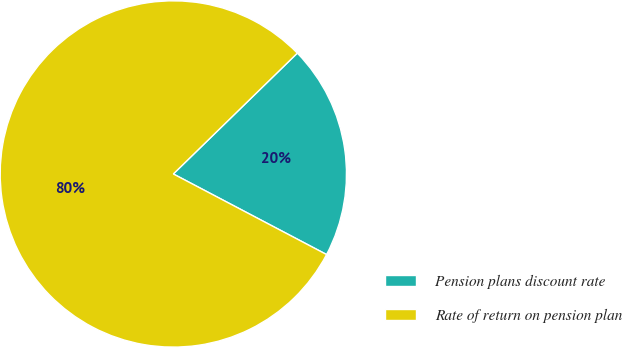<chart> <loc_0><loc_0><loc_500><loc_500><pie_chart><fcel>Pension plans discount rate<fcel>Rate of return on pension plan<nl><fcel>20.0%<fcel>80.0%<nl></chart> 